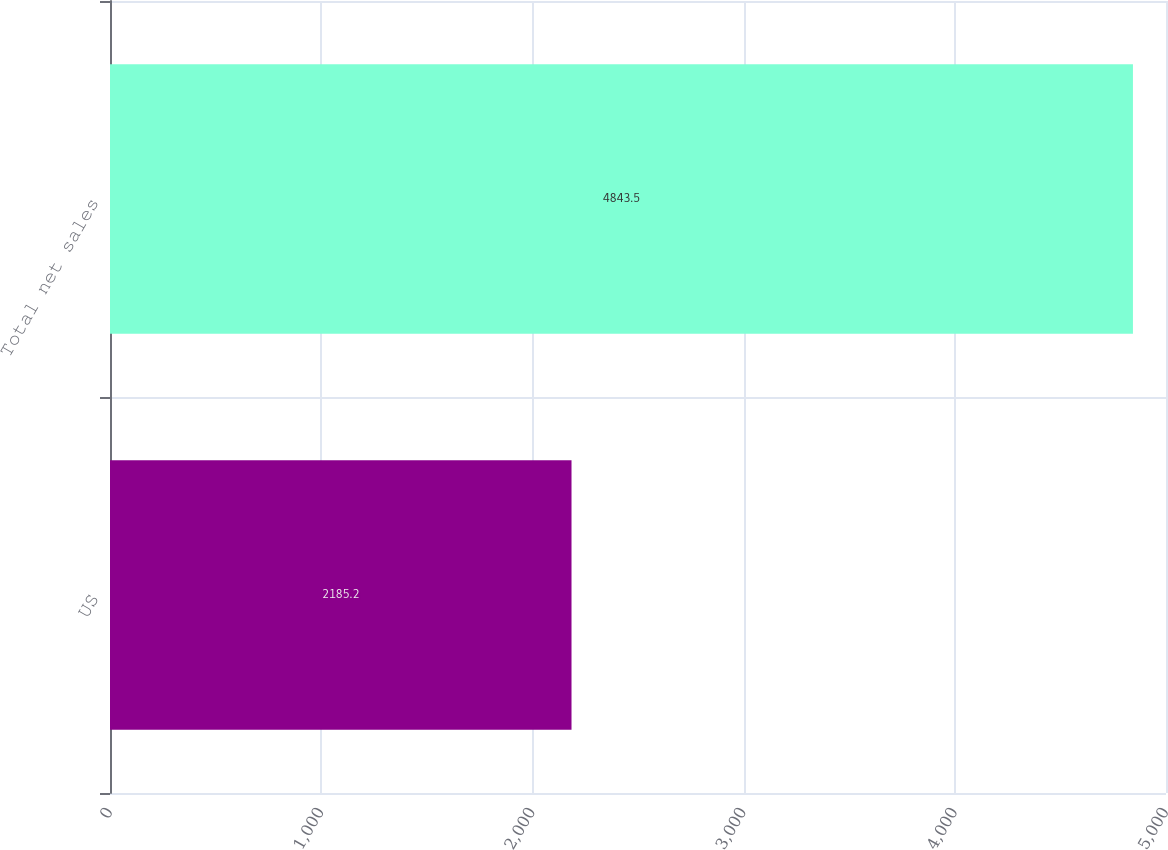Convert chart. <chart><loc_0><loc_0><loc_500><loc_500><bar_chart><fcel>US<fcel>Total net sales<nl><fcel>2185.2<fcel>4843.5<nl></chart> 